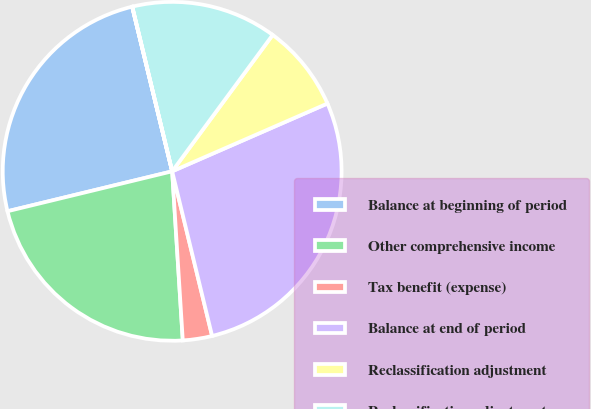Convert chart. <chart><loc_0><loc_0><loc_500><loc_500><pie_chart><fcel>Balance at beginning of period<fcel>Other comprehensive income<fcel>Tax benefit (expense)<fcel>Balance at end of period<fcel>Reclassification adjustment<fcel>Reclassification adjustment -<fcel>Tax expense (benefit)<nl><fcel>24.99%<fcel>22.21%<fcel>2.79%<fcel>27.76%<fcel>8.34%<fcel>13.89%<fcel>0.01%<nl></chart> 